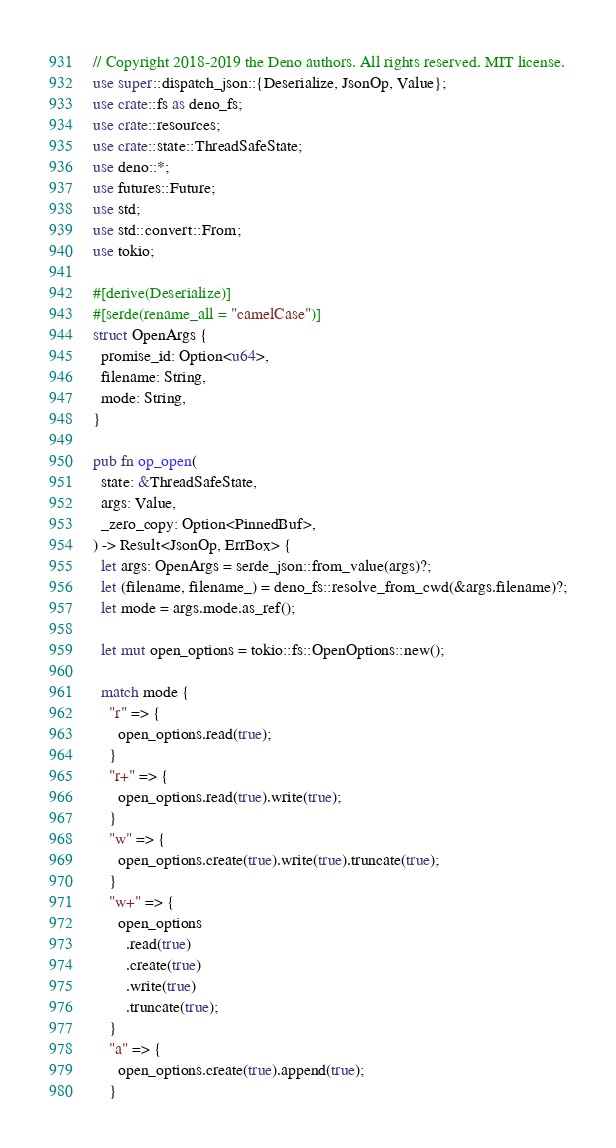Convert code to text. <code><loc_0><loc_0><loc_500><loc_500><_Rust_>// Copyright 2018-2019 the Deno authors. All rights reserved. MIT license.
use super::dispatch_json::{Deserialize, JsonOp, Value};
use crate::fs as deno_fs;
use crate::resources;
use crate::state::ThreadSafeState;
use deno::*;
use futures::Future;
use std;
use std::convert::From;
use tokio;

#[derive(Deserialize)]
#[serde(rename_all = "camelCase")]
struct OpenArgs {
  promise_id: Option<u64>,
  filename: String,
  mode: String,
}

pub fn op_open(
  state: &ThreadSafeState,
  args: Value,
  _zero_copy: Option<PinnedBuf>,
) -> Result<JsonOp, ErrBox> {
  let args: OpenArgs = serde_json::from_value(args)?;
  let (filename, filename_) = deno_fs::resolve_from_cwd(&args.filename)?;
  let mode = args.mode.as_ref();

  let mut open_options = tokio::fs::OpenOptions::new();

  match mode {
    "r" => {
      open_options.read(true);
    }
    "r+" => {
      open_options.read(true).write(true);
    }
    "w" => {
      open_options.create(true).write(true).truncate(true);
    }
    "w+" => {
      open_options
        .read(true)
        .create(true)
        .write(true)
        .truncate(true);
    }
    "a" => {
      open_options.create(true).append(true);
    }</code> 